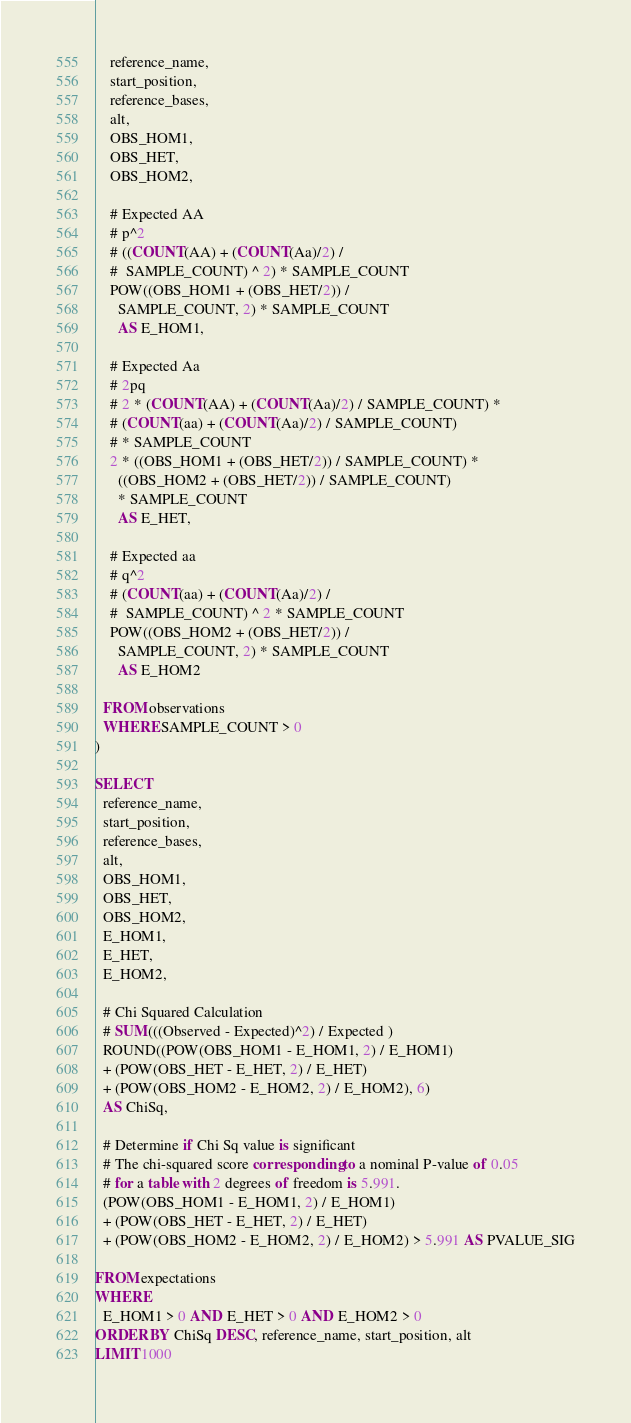Convert code to text. <code><loc_0><loc_0><loc_500><loc_500><_SQL_>    reference_name,
    start_position,
    reference_bases,
    alt,
    OBS_HOM1,
    OBS_HET,
    OBS_HOM2,

    # Expected AA
    # p^2
    # ((COUNT(AA) + (COUNT(Aa)/2) /
    #  SAMPLE_COUNT) ^ 2) * SAMPLE_COUNT
    POW((OBS_HOM1 + (OBS_HET/2)) /
      SAMPLE_COUNT, 2) * SAMPLE_COUNT
      AS E_HOM1,

    # Expected Aa
    # 2pq
    # 2 * (COUNT(AA) + (COUNT(Aa)/2) / SAMPLE_COUNT) *
    # (COUNT(aa) + (COUNT(Aa)/2) / SAMPLE_COUNT)
    # * SAMPLE_COUNT
    2 * ((OBS_HOM1 + (OBS_HET/2)) / SAMPLE_COUNT) *
      ((OBS_HOM2 + (OBS_HET/2)) / SAMPLE_COUNT)
      * SAMPLE_COUNT
      AS E_HET,

    # Expected aa
    # q^2
    # (COUNT(aa) + (COUNT(Aa)/2) /
    #  SAMPLE_COUNT) ^ 2 * SAMPLE_COUNT
    POW((OBS_HOM2 + (OBS_HET/2)) /
      SAMPLE_COUNT, 2) * SAMPLE_COUNT
      AS E_HOM2

  FROM observations
  WHERE SAMPLE_COUNT > 0
)

SELECT
  reference_name,
  start_position,
  reference_bases,
  alt,
  OBS_HOM1,
  OBS_HET,
  OBS_HOM2,
  E_HOM1,
  E_HET,
  E_HOM2,

  # Chi Squared Calculation
  # SUM(((Observed - Expected)^2) / Expected )
  ROUND((POW(OBS_HOM1 - E_HOM1, 2) / E_HOM1)
  + (POW(OBS_HET - E_HET, 2) / E_HET)
  + (POW(OBS_HOM2 - E_HOM2, 2) / E_HOM2), 6)
  AS ChiSq,

  # Determine if Chi Sq value is significant
  # The chi-squared score corresponding to a nominal P-value of 0.05
  # for a table with 2 degrees of freedom is 5.991.
  (POW(OBS_HOM1 - E_HOM1, 2) / E_HOM1)
  + (POW(OBS_HET - E_HET, 2) / E_HET)
  + (POW(OBS_HOM2 - E_HOM2, 2) / E_HOM2) > 5.991 AS PVALUE_SIG

FROM expectations
WHERE
  E_HOM1 > 0 AND E_HET > 0 AND E_HOM2 > 0
ORDER BY ChiSq DESC, reference_name, start_position, alt
LIMIT 1000
</code> 